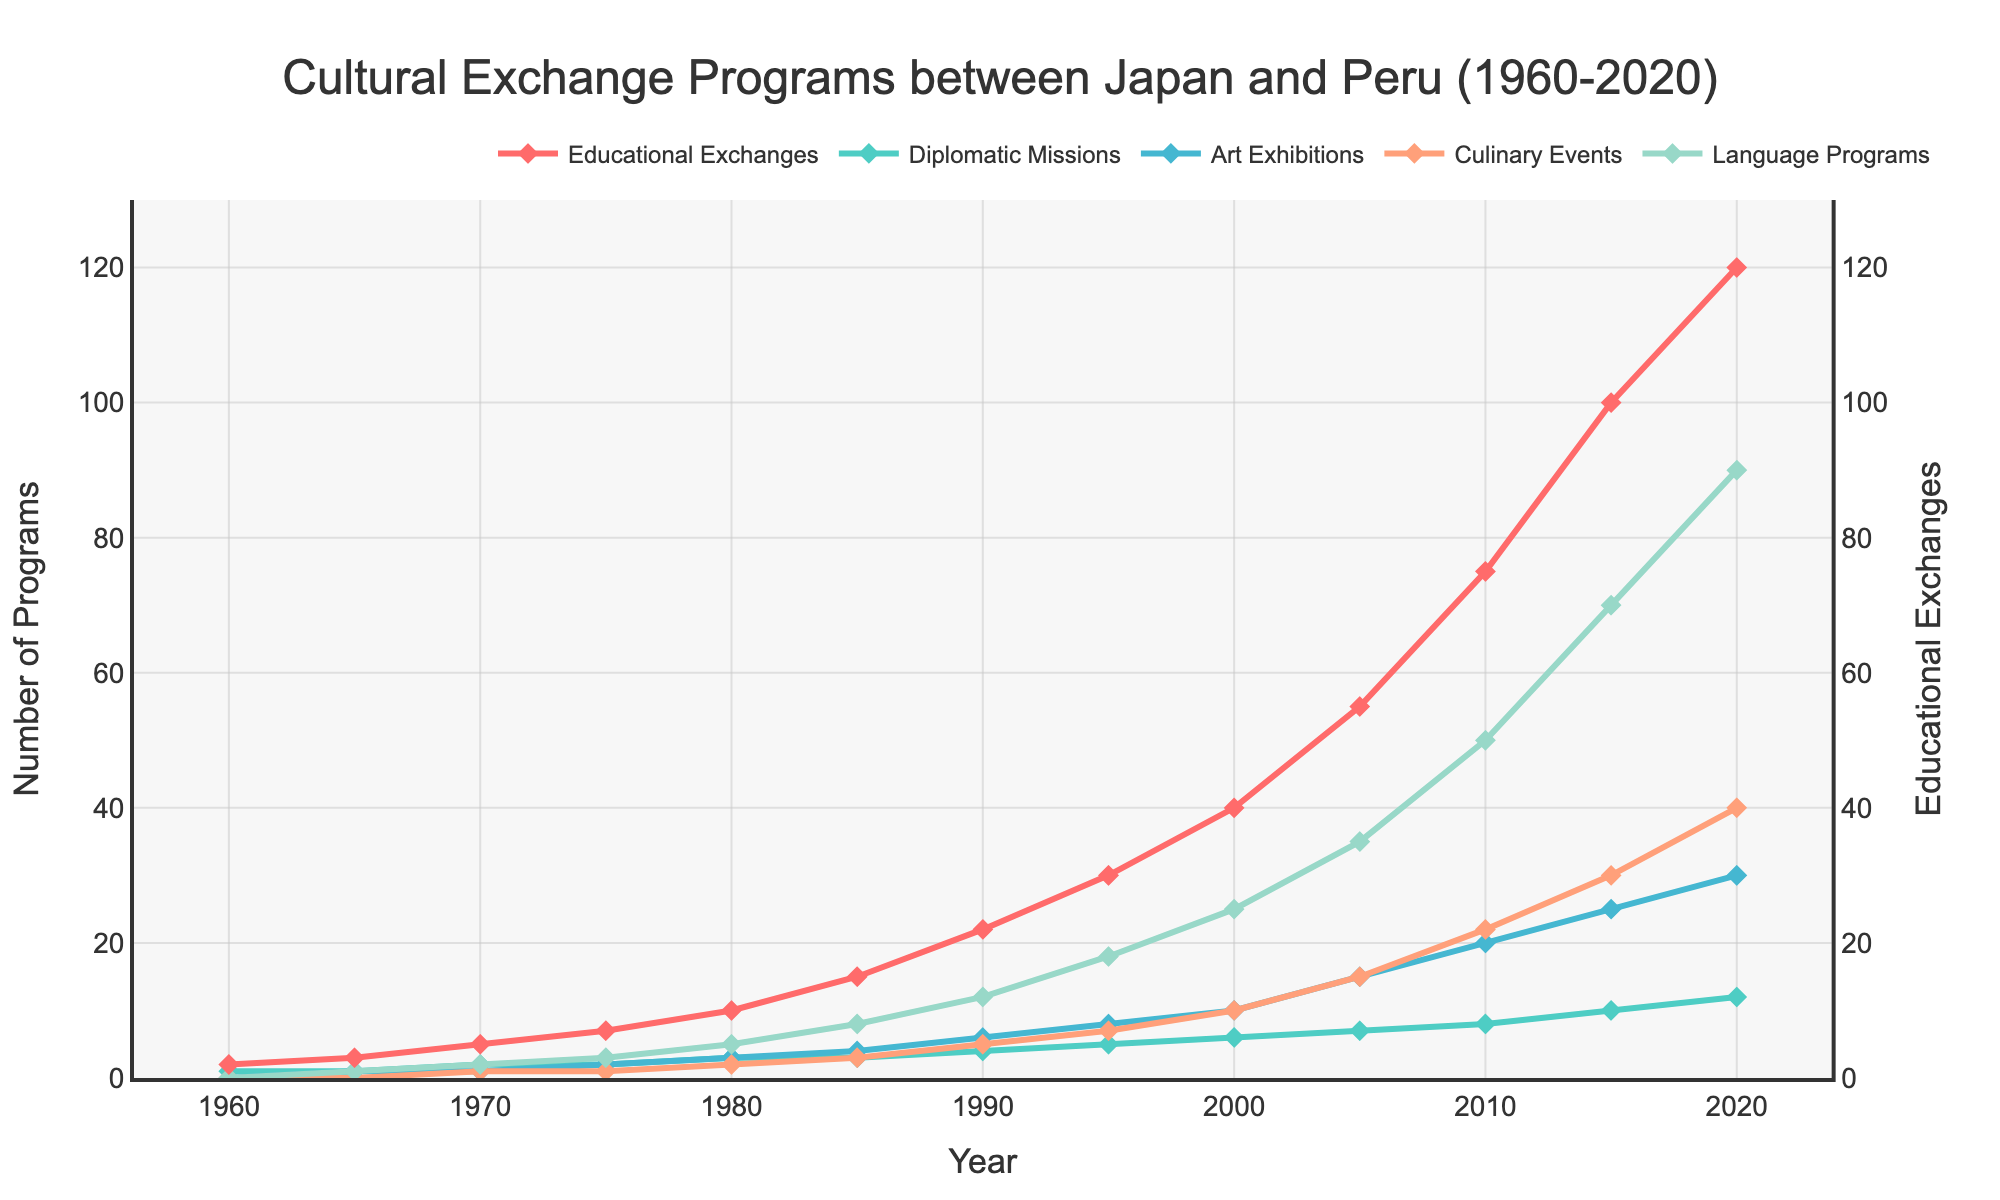What's the total number of Art Exhibitions held in 1980 and 1990 combined? In 1980, there were 3 Art Exhibitions. In 1990, there were 6 Art Exhibitions. Their total is 3 + 6 = 9.
Answer: 9 Which program type increased the most between 2015 and 2020? By examining the figure, we see that Educational Exchanges increased from 100 to 120 (+20), Diplomatic Missions from 10 to 12 (+2), Art Exhibitions from 25 to 30 (+5), Culinary Events from 30 to 40 (+10), and Language Programs from 70 to 90 (+20). So, the Educational Exchanges and Language Programs both increased by 20.
Answer: Educational Exchanges, Language Programs Are Language Programs or Culinary Events more frequent in 2000? In the year 2000, the number of Language Programs is 25, and the number of Culinary Events is 10. Thus, Language Programs are more frequent.
Answer: Language Programs How many types of cultural exchange programs reached their highest number in 2020? By looking at each type's trend lines, we see that Educational Exchanges (120), Diplomatic Missions (12), Art Exhibitions (30), Culinary Events (40), and Language Programs (90) all reached their peaks in 2020. That makes a total of 5.
Answer: 5 What's the difference in the number of Diplomatic Missions between 1995 and 2015? The number of Diplomatic Missions in 1995 is 5, and in 2015 is 10. The difference is 10 - 5 = 5.
Answer: 5 Which program type experienced the least growth between 1960 and 1970? The increase in each program type from 1960 to 1970: Educational Exchanges increased by 3 (from 2 to 5), Diplomatic Missions increased by 1 (from 1 to 2), Art Exhibitions increased by 1 (from 0 to 1), Culinary Events increased by 1 (from 0 to 1), and Language Programs increased by 2 (from 0 to 2). The smallest growth is in Diplomatic Missions, Art Exhibitions, and Culinary Events, all increasing by just 1.
Answer: Diplomatic Missions, Art Exhibitions, Culinary Events Based on the trends, which program type saw a significant increase around the 2000s? The number of Educational Exchanges saw a noticeable spike around the 2000s, increasing from 40 in 2000 to 55 in 2005, which is a significant rise.
Answer: Educational Exchanges 